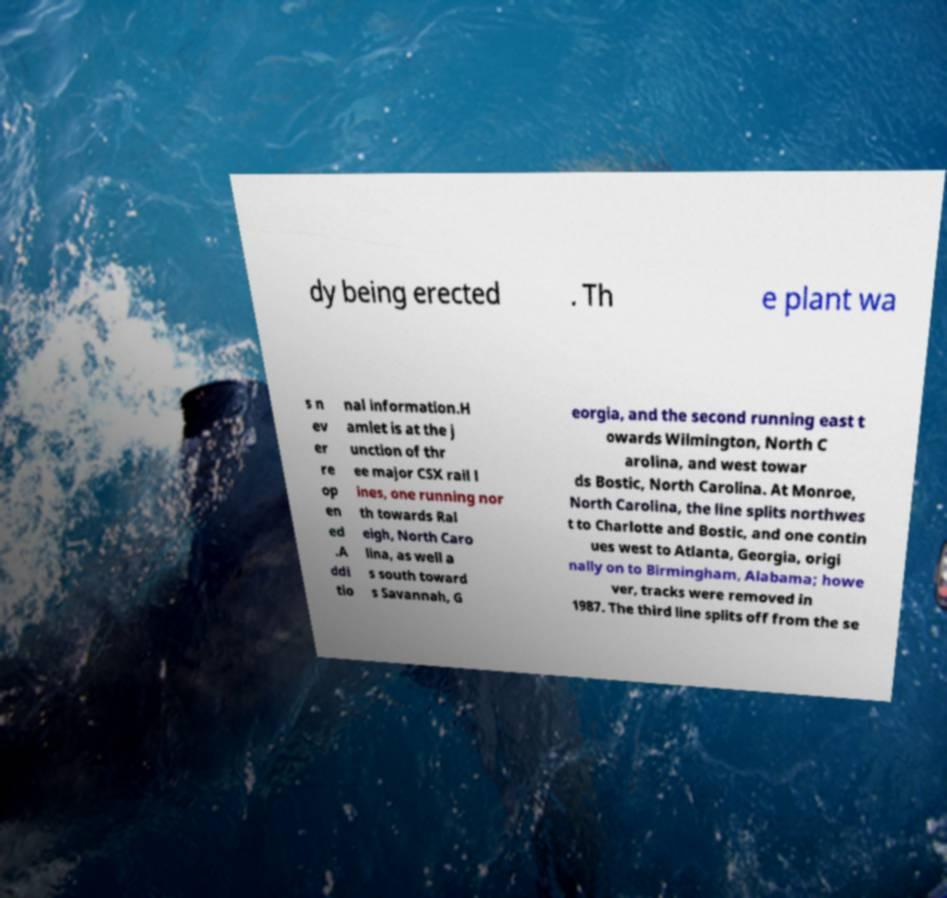Could you extract and type out the text from this image? dy being erected . Th e plant wa s n ev er re op en ed .A ddi tio nal information.H amlet is at the j unction of thr ee major CSX rail l ines, one running nor th towards Ral eigh, North Caro lina, as well a s south toward s Savannah, G eorgia, and the second running east t owards Wilmington, North C arolina, and west towar ds Bostic, North Carolina. At Monroe, North Carolina, the line splits northwes t to Charlotte and Bostic, and one contin ues west to Atlanta, Georgia, origi nally on to Birmingham, Alabama; howe ver, tracks were removed in 1987. The third line splits off from the se 